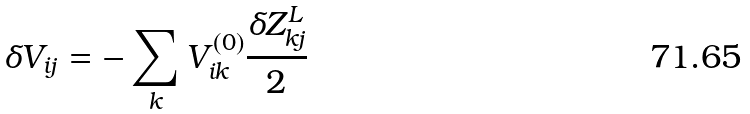<formula> <loc_0><loc_0><loc_500><loc_500>\delta V _ { i j } = - \sum _ { k } V ^ { ( 0 ) } _ { i k } \frac { \delta Z ^ { L } _ { k j } } { 2 }</formula> 